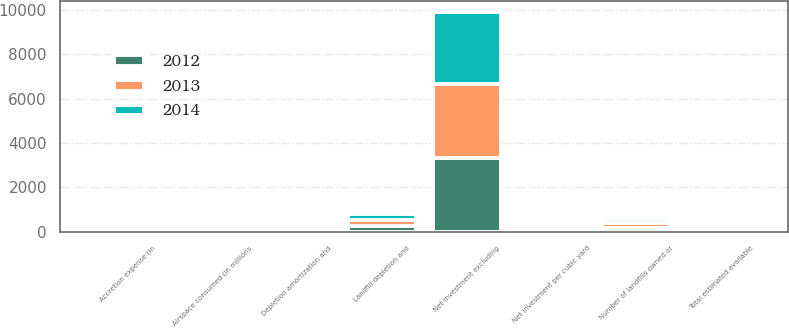Convert chart to OTSL. <chart><loc_0><loc_0><loc_500><loc_500><stacked_bar_chart><ecel><fcel>Number of landfills owned or<fcel>Net investment excluding<fcel>Total estimated available<fcel>Net investment per cubic yard<fcel>Landfill depletion and<fcel>Accretion expense (in<fcel>Airspace consumed (in millions<fcel>Depletion amortization and<nl><fcel>2012<fcel>189<fcel>3348.7<fcel>78<fcel>0.69<fcel>263<fcel>78<fcel>74.6<fcel>4.57<nl><fcel>2013<fcel>190<fcel>3305<fcel>78<fcel>0.68<fcel>261.9<fcel>76.6<fcel>73.3<fcel>4.62<nl><fcel>2014<fcel>191<fcel>3256.1<fcel>78<fcel>0.68<fcel>257.6<fcel>78.4<fcel>73.6<fcel>4.57<nl></chart> 